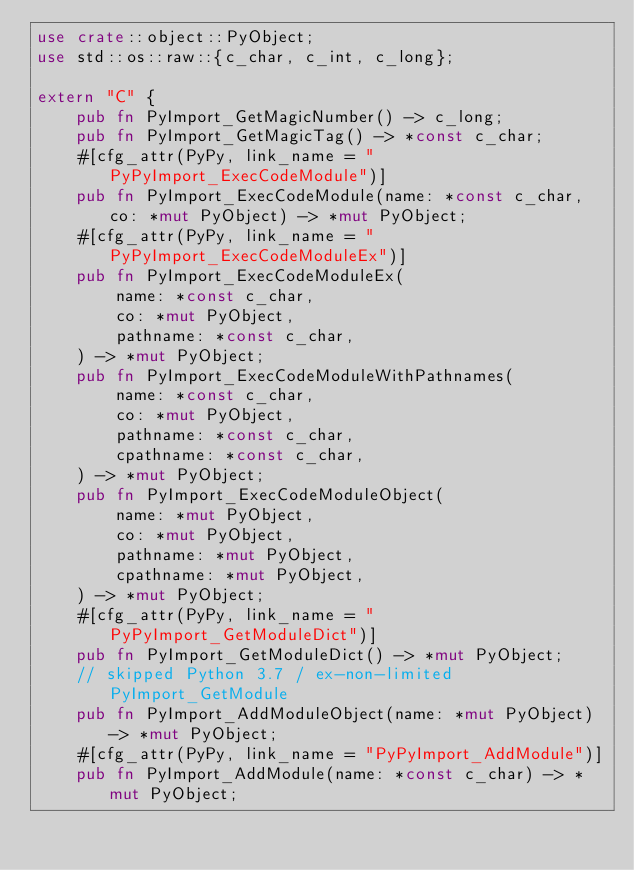Convert code to text. <code><loc_0><loc_0><loc_500><loc_500><_Rust_>use crate::object::PyObject;
use std::os::raw::{c_char, c_int, c_long};

extern "C" {
    pub fn PyImport_GetMagicNumber() -> c_long;
    pub fn PyImport_GetMagicTag() -> *const c_char;
    #[cfg_attr(PyPy, link_name = "PyPyImport_ExecCodeModule")]
    pub fn PyImport_ExecCodeModule(name: *const c_char, co: *mut PyObject) -> *mut PyObject;
    #[cfg_attr(PyPy, link_name = "PyPyImport_ExecCodeModuleEx")]
    pub fn PyImport_ExecCodeModuleEx(
        name: *const c_char,
        co: *mut PyObject,
        pathname: *const c_char,
    ) -> *mut PyObject;
    pub fn PyImport_ExecCodeModuleWithPathnames(
        name: *const c_char,
        co: *mut PyObject,
        pathname: *const c_char,
        cpathname: *const c_char,
    ) -> *mut PyObject;
    pub fn PyImport_ExecCodeModuleObject(
        name: *mut PyObject,
        co: *mut PyObject,
        pathname: *mut PyObject,
        cpathname: *mut PyObject,
    ) -> *mut PyObject;
    #[cfg_attr(PyPy, link_name = "PyPyImport_GetModuleDict")]
    pub fn PyImport_GetModuleDict() -> *mut PyObject;
    // skipped Python 3.7 / ex-non-limited PyImport_GetModule
    pub fn PyImport_AddModuleObject(name: *mut PyObject) -> *mut PyObject;
    #[cfg_attr(PyPy, link_name = "PyPyImport_AddModule")]
    pub fn PyImport_AddModule(name: *const c_char) -> *mut PyObject;</code> 